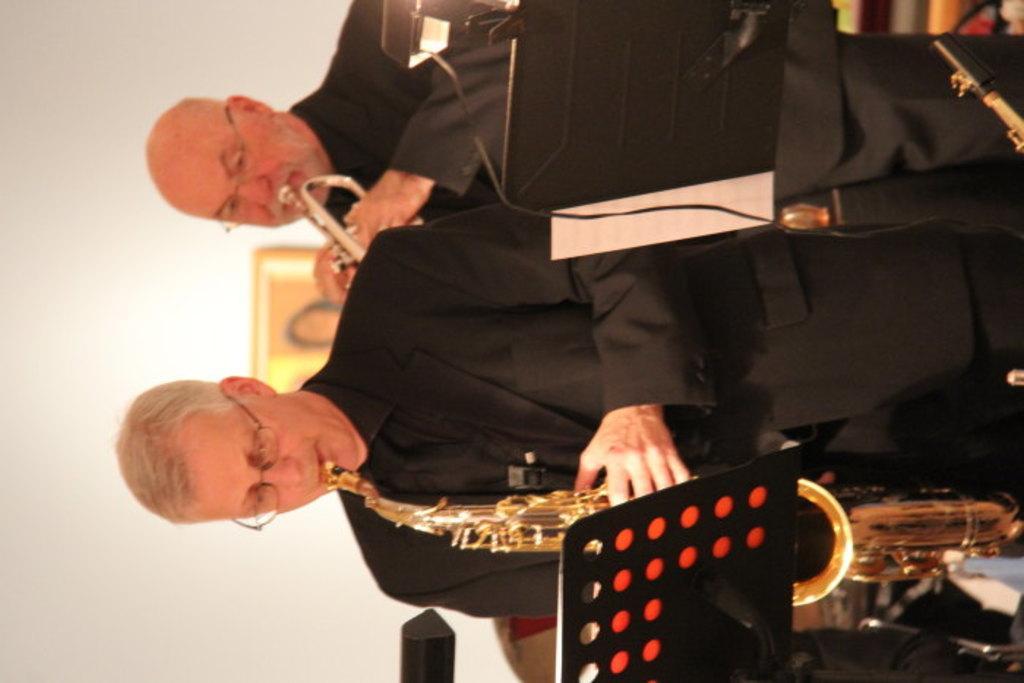Describe this image in one or two sentences. In the center of the image we can see two persons are standing and they are playing some musical instruments. In front of them, we can see some objects. In the background there is a wall and a few other objects. 